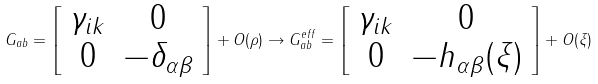<formula> <loc_0><loc_0><loc_500><loc_500>G _ { a b } = \left [ \begin{array} { c c } \gamma _ { i k } & 0 \\ 0 & - \delta _ { \alpha \beta } \end{array} \right ] + O ( \rho ) \rightarrow G _ { a b } ^ { e f f } = \left [ \begin{array} { c c } \gamma _ { i k } & 0 \\ 0 & - h _ { \alpha \beta } ( \xi ) \end{array} \right ] + O ( \xi )</formula> 